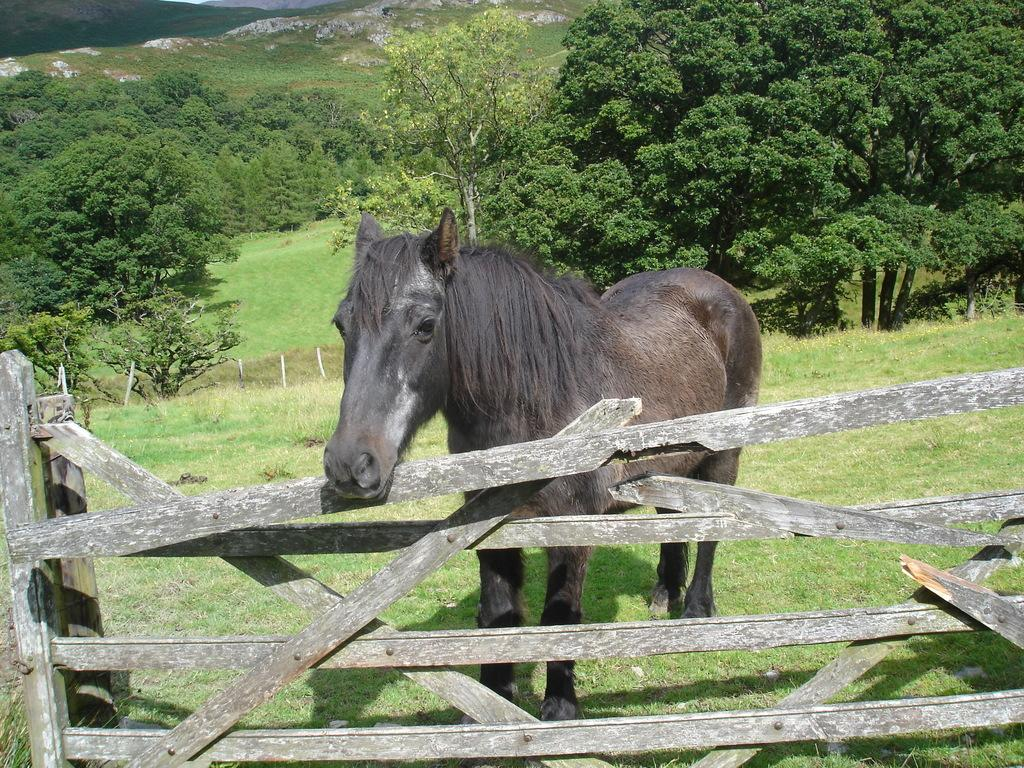What animal can be seen in the image? There is a horse in the image. What is the horse standing near? There is a fence in the image. What structures are present in the image? There are poles in the image. What type of landscape is visible in the image? There are hills and trees in the image. What is visible at the bottom of the image? There is ground visible at the bottom of the image. What type of voice can be heard coming from the horse in the image? Horses do not have the ability to produce human-like voices, so there is no voice present in the image. 